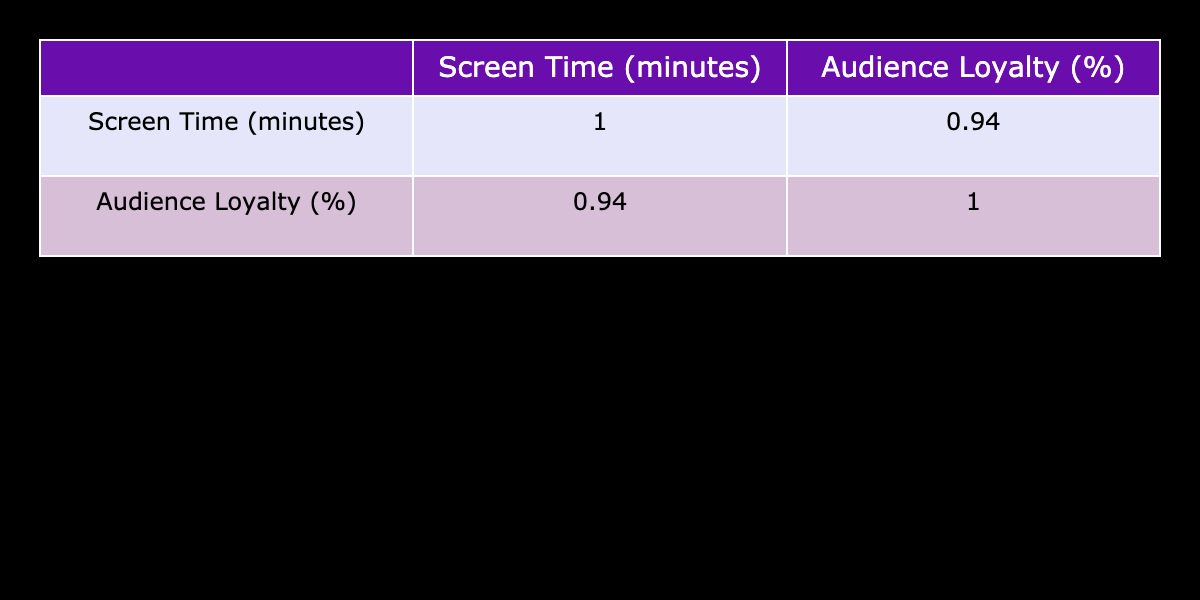What is the audience loyalty percentage for Lily James? Referring to the table, Lily James has an audience loyalty percentage of 92.
Answer: 92 What actor has the highest screen time? Looking at the table, Florence Pugh has the highest screen time at 60 minutes.
Answer: 60 Is Maya Hawke's audience loyalty greater than 80 percent? In the table, Maya Hawke has an audience loyalty of 80 percent, which is equal but not greater.
Answer: No What is the average screen time of all actors in the table? Summing the screen times: (45 + 50 + 30 + 40 + 55 + 35 + 60 + 25 + 50 + 55) = 445 minutes. There are 10 actors, so the average is 445/10 = 44.5 minutes.
Answer: 44.5 Which actor has a screen time of 35 minutes? The table shows that Timothée Chalamet has a screen time of 35 minutes.
Answer: Timothée Chalamet Does audience loyalty tend to increase with longer screen time? By analyzing the correlation between screen time and audience loyalty in the table, longer screen times seem to correlate with higher audience loyalty (e.g., Florence Pugh with 60 minutes has 95 percent loyalty).
Answer: Yes What is the difference in audience loyalty between the actors with the most and least screen time? The actor with the most screen time is Florence Pugh (60 minutes, 95% loyalty) and the least is Noah Centineo (25 minutes, 70% loyalty). The difference is 95 - 70 = 25 percent.
Answer: 25 Which actors have audience loyalty percentages above 90? By checking the table, the actors with audience loyalty percentages above 90 are Ryan Gosling (90), Lily James (92), and Florence Pugh (95).
Answer: Ryan Gosling, Lily James, Florence Pugh What is the audience loyalty for Ryan Gosling and how does it compare to that of Emma Stone? The table shows Ryan Gosling has 90% audience loyalty while Emma Stone has 88%. Ryan Gosling's loyalty is higher by 2%.
Answer: Higher by 2% 